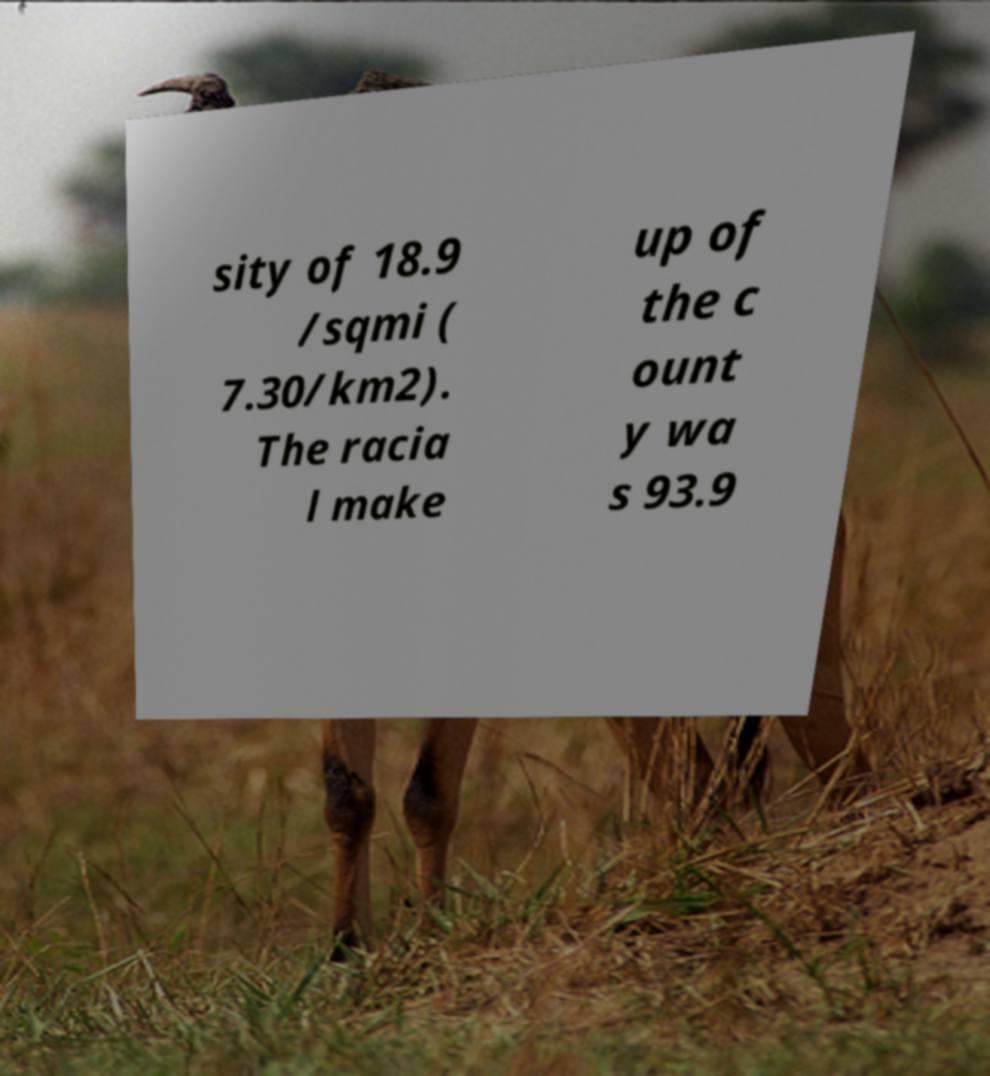Could you extract and type out the text from this image? sity of 18.9 /sqmi ( 7.30/km2). The racia l make up of the c ount y wa s 93.9 